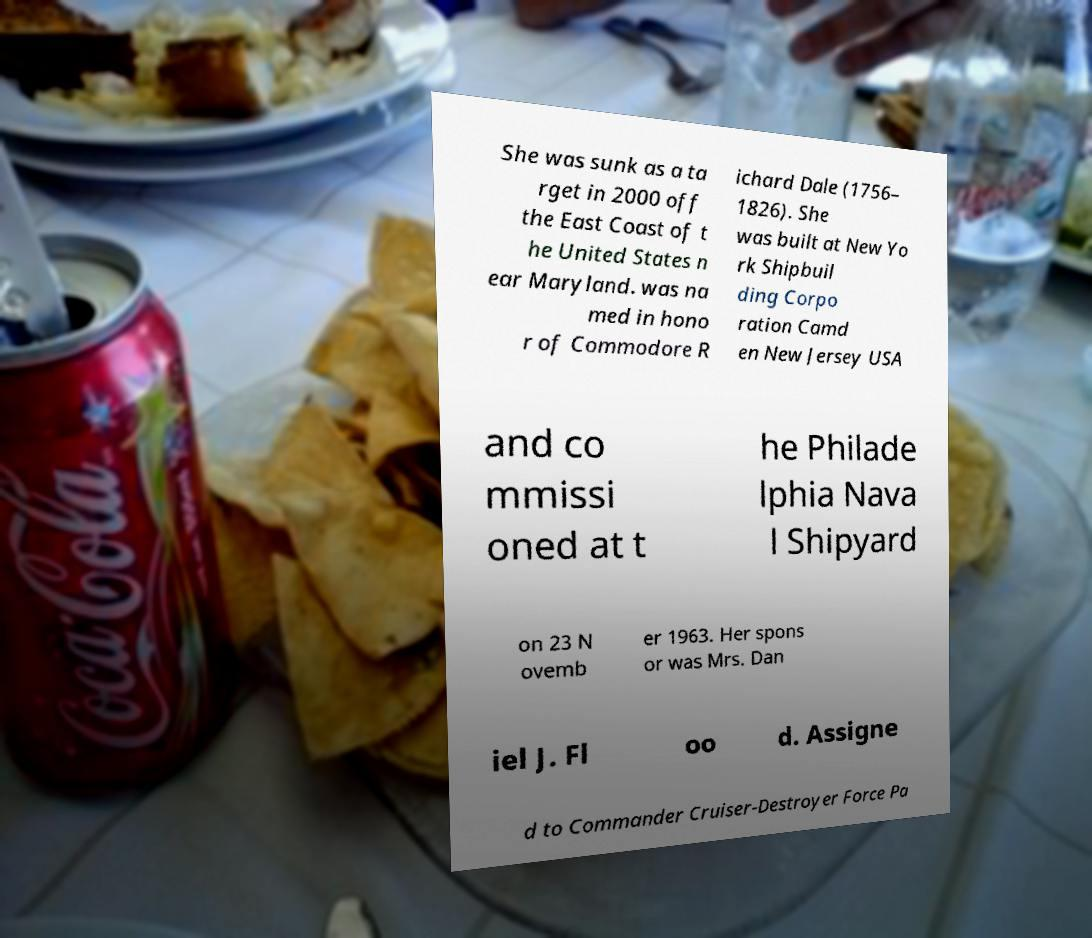Could you extract and type out the text from this image? She was sunk as a ta rget in 2000 off the East Coast of t he United States n ear Maryland. was na med in hono r of Commodore R ichard Dale (1756– 1826). She was built at New Yo rk Shipbuil ding Corpo ration Camd en New Jersey USA and co mmissi oned at t he Philade lphia Nava l Shipyard on 23 N ovemb er 1963. Her spons or was Mrs. Dan iel J. Fl oo d. Assigne d to Commander Cruiser-Destroyer Force Pa 